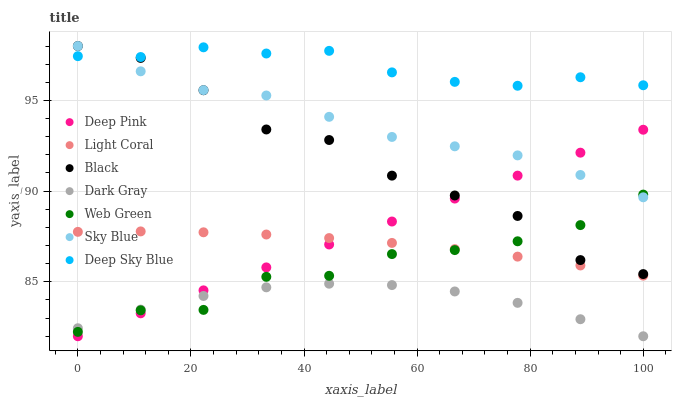Does Dark Gray have the minimum area under the curve?
Answer yes or no. Yes. Does Deep Sky Blue have the maximum area under the curve?
Answer yes or no. Yes. Does Deep Pink have the minimum area under the curve?
Answer yes or no. No. Does Deep Pink have the maximum area under the curve?
Answer yes or no. No. Is Deep Pink the smoothest?
Answer yes or no. Yes. Is Black the roughest?
Answer yes or no. Yes. Is Web Green the smoothest?
Answer yes or no. No. Is Web Green the roughest?
Answer yes or no. No. Does Dark Gray have the lowest value?
Answer yes or no. Yes. Does Web Green have the lowest value?
Answer yes or no. No. Does Sky Blue have the highest value?
Answer yes or no. Yes. Does Deep Pink have the highest value?
Answer yes or no. No. Is Dark Gray less than Black?
Answer yes or no. Yes. Is Deep Sky Blue greater than Web Green?
Answer yes or no. Yes. Does Sky Blue intersect Deep Pink?
Answer yes or no. Yes. Is Sky Blue less than Deep Pink?
Answer yes or no. No. Is Sky Blue greater than Deep Pink?
Answer yes or no. No. Does Dark Gray intersect Black?
Answer yes or no. No. 